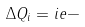Convert formula to latex. <formula><loc_0><loc_0><loc_500><loc_500>\Delta Q _ { i } = i e -</formula> 